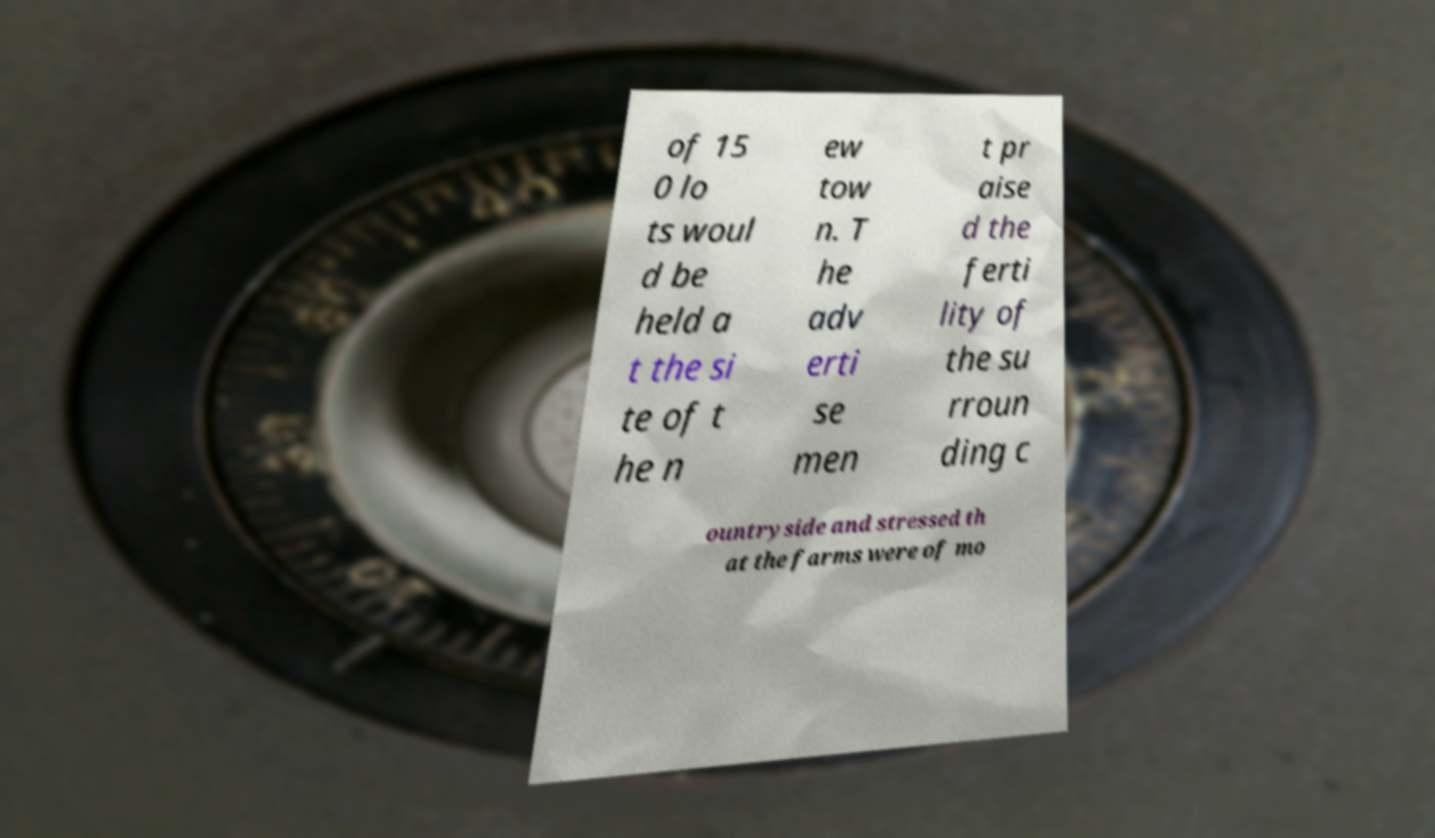Could you assist in decoding the text presented in this image and type it out clearly? of 15 0 lo ts woul d be held a t the si te of t he n ew tow n. T he adv erti se men t pr aise d the ferti lity of the su rroun ding c ountryside and stressed th at the farms were of mo 